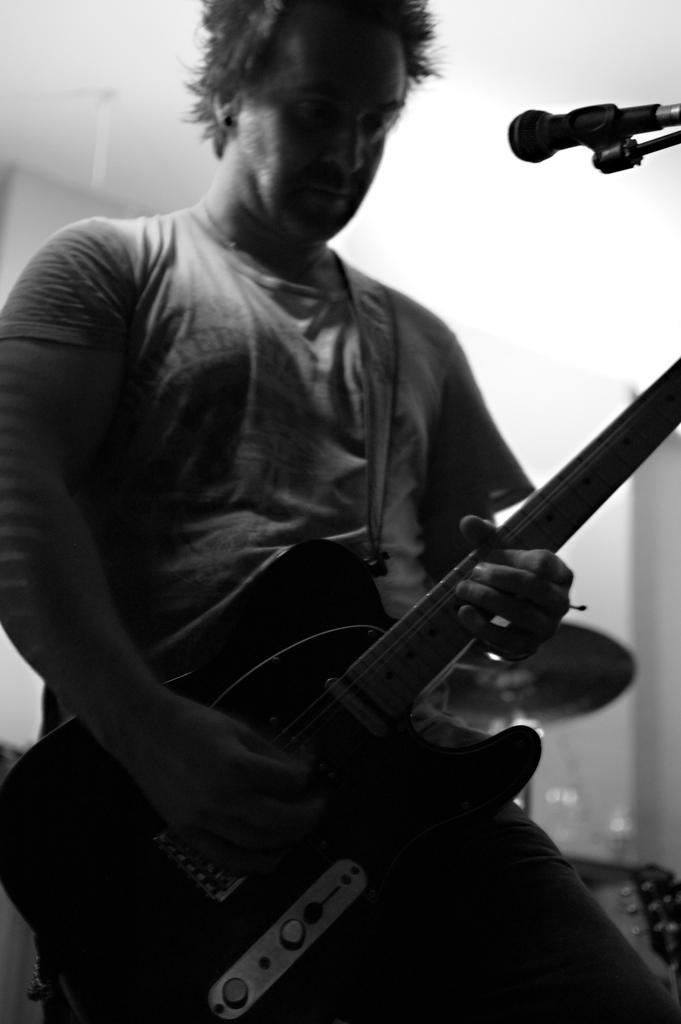What is the main subject of the image? The main subject of the image is a man. What is the man doing in the image? The man is standing and playing the guitar. What object is the man holding in his hand? The man is holding a guitar in his hand. What is the purpose of the microphone in front of the man? The microphone is likely used for amplifying the man's voice while he plays the guitar. Can you see any quicksand in the image? No, there is no quicksand present in the image. What type of wood is the man using to play the guitar? The provided facts do not mention any specific type of wood or material used for the guitar. 